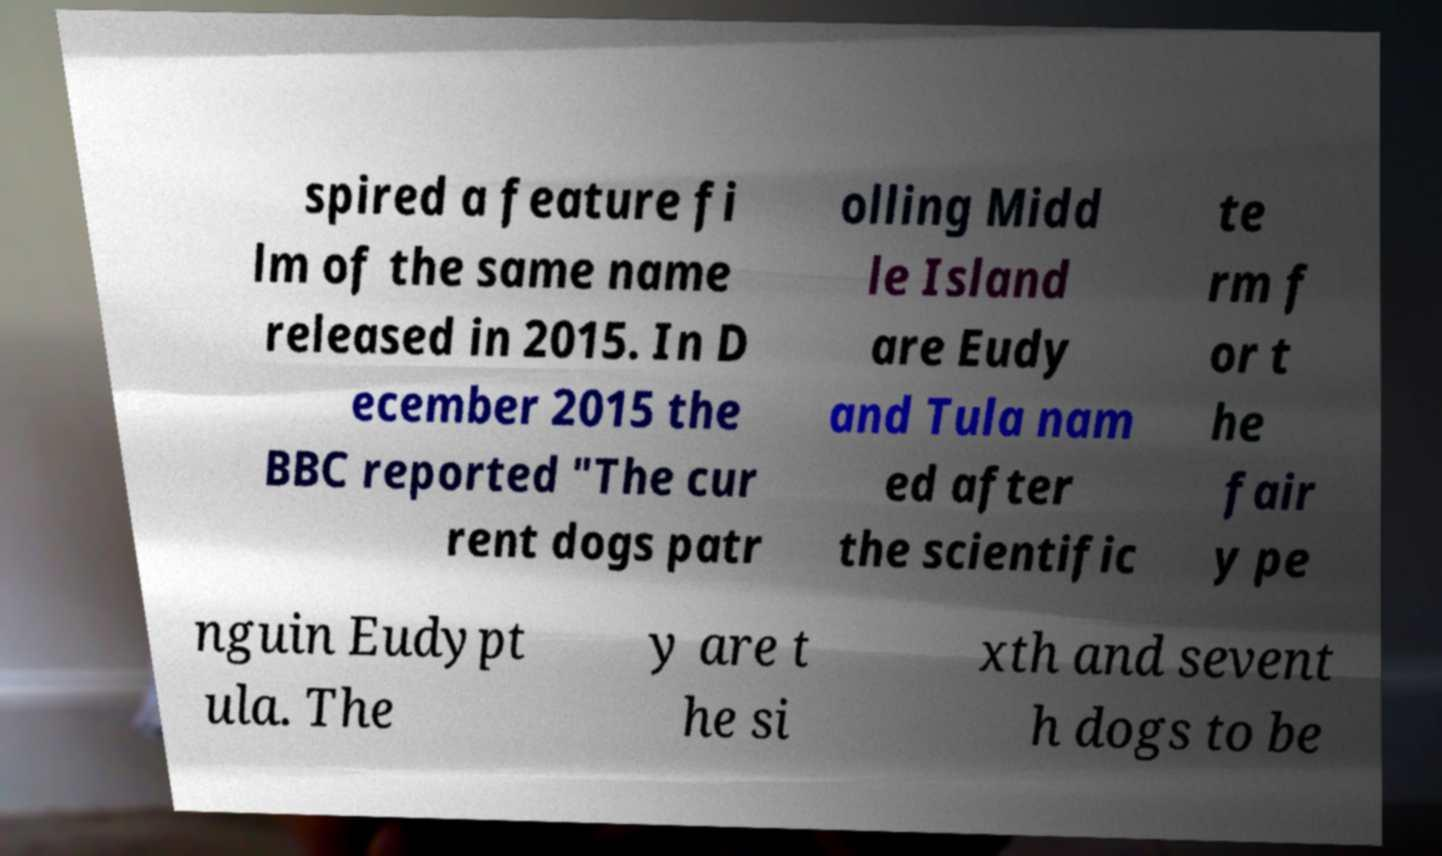Can you accurately transcribe the text from the provided image for me? spired a feature fi lm of the same name released in 2015. In D ecember 2015 the BBC reported "The cur rent dogs patr olling Midd le Island are Eudy and Tula nam ed after the scientific te rm f or t he fair y pe nguin Eudypt ula. The y are t he si xth and sevent h dogs to be 